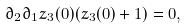<formula> <loc_0><loc_0><loc_500><loc_500>\partial _ { 2 } \partial _ { 1 } z _ { 3 } ( 0 ) ( z _ { 3 } ( 0 ) + 1 ) = 0 ,</formula> 